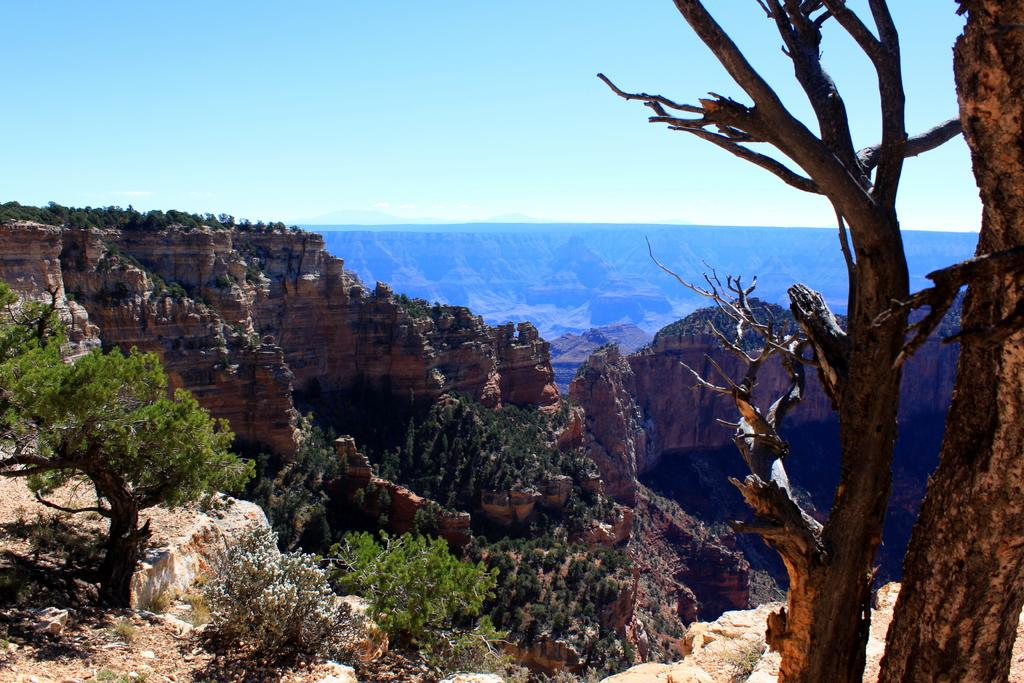What is located on the right side of the image? There is a rock and a tree on the right side of the image. What can be seen in the middle of the image? There are mountains, trees, and shrubs visible in the middle of the image. What is visible at the top of the image? The sky is visible at the top of the image. How many boys are holding a jelly cord in the image? There are no boys or jelly cords present in the image. What type of cord is used to connect the trees in the image? There is no cord connecting the trees in the image; the trees are separate entities. 